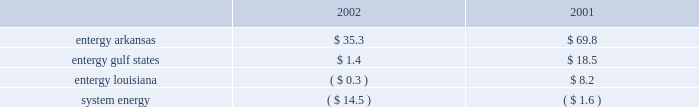Domestic utility companies and system energy notes to respective financial statements derived from another portion of the entity that continues to apply sfas 71 should not be written off ; rather , they should be considered regulatory assets of the segment that will continue to apply sfas 71 .
See note 2 to the domestic utility companies and system energy financial statements for discussion of transition to competition activity in the retail regulatory jurisdictions served by the domestic utility companies .
Only texas currently has an enacted retail open access law , but entergy believes that significant issues remain to be addressed by regulators , and the enacted law does not provide sufficient detail to reasonably determine the impact on entergy gulf states' regulated operations .
Cash and cash equivalents entergy considers all unrestricted highly liquid debt instruments purchased with an original maturity of three months or less to be cash equivalents .
Investments with original maturities of more than three months are classified as other temporary investments on the balance sheet .
Investments entergy applies the provisions of sfas 115 , 201caccounting for investments for certain debt and equity securities , 201d in accounting for investments in decommissioning trust funds .
As a result , entergy records the decommissioning trust funds at their fair value on the balance sheet .
As of december 31 , 2002 and 2001 , the fair value of the securities held in such funds differs from the amounts deposited plus the earnings on the deposits by the following ( in millions ) : .
In accordance with the regulatory treatment for decommissioning trust funds , entergy arkansas , entergy gulf states ( for the regulated portion of river bend ) , and entergy louisiana have recorded an offsetting amount of unrealized gains/ ( losses ) on investment securities in accumulated depreciation .
For the nonregulated portion of river bend , entergy gulf states has recorded an offsetting amount of unrealized gains/ ( losses ) in other deferred credits .
System energy's offsetting amount of unrealized gains/ ( losses ) on investment securities is in other regulatory liabilities .
Derivatives and hedging entergy implemented sfas 133 , 201caccounting for derivative instruments and hedging activities 201d on january 1 , 2001 .
The statement requires that all derivatives be recognized in the balance sheet , either as assets or liabilities , at fair value .
The changes in the fair value of derivatives are recorded each period in current earnings or other comprehensive income , depending on whether a derivative is designated as part of a hedge transaction and , if it is , the type of hedge transaction .
For cash-flow hedge transactions in which entergy is hedging the variability of cash flows related to a variable-rate asset , liability , or forecasted transaction , changes in the fair value of the derivative instrument are reported in other comprehensive income .
The gains and losses on the derivative instrument that are reported in other comprehensive income are reclassified as earnings in the periods in which earnings are impacted by the variability of the cash flows of the hedged item .
The ineffective portions of all hedges are recognized in current- period earnings .
Contracts for commodities that will be delivered in quantities expected to be used or sold in the ordinary course of business , including certain purchases and sales of power and fuel , are not classified as derivatives. .
What is the percent change in the difference in the fair value of the securities held in decommissioning trust funds and the amounts deposited plus the earnings on the deposits from 2001 to 2002 for entergy gulf states? 
Computations: ((18.5 - 1.4) / 1.4)
Answer: 12.21429. Domestic utility companies and system energy notes to respective financial statements derived from another portion of the entity that continues to apply sfas 71 should not be written off ; rather , they should be considered regulatory assets of the segment that will continue to apply sfas 71 .
See note 2 to the domestic utility companies and system energy financial statements for discussion of transition to competition activity in the retail regulatory jurisdictions served by the domestic utility companies .
Only texas currently has an enacted retail open access law , but entergy believes that significant issues remain to be addressed by regulators , and the enacted law does not provide sufficient detail to reasonably determine the impact on entergy gulf states' regulated operations .
Cash and cash equivalents entergy considers all unrestricted highly liquid debt instruments purchased with an original maturity of three months or less to be cash equivalents .
Investments with original maturities of more than three months are classified as other temporary investments on the balance sheet .
Investments entergy applies the provisions of sfas 115 , 201caccounting for investments for certain debt and equity securities , 201d in accounting for investments in decommissioning trust funds .
As a result , entergy records the decommissioning trust funds at their fair value on the balance sheet .
As of december 31 , 2002 and 2001 , the fair value of the securities held in such funds differs from the amounts deposited plus the earnings on the deposits by the following ( in millions ) : .
In accordance with the regulatory treatment for decommissioning trust funds , entergy arkansas , entergy gulf states ( for the regulated portion of river bend ) , and entergy louisiana have recorded an offsetting amount of unrealized gains/ ( losses ) on investment securities in accumulated depreciation .
For the nonregulated portion of river bend , entergy gulf states has recorded an offsetting amount of unrealized gains/ ( losses ) in other deferred credits .
System energy's offsetting amount of unrealized gains/ ( losses ) on investment securities is in other regulatory liabilities .
Derivatives and hedging entergy implemented sfas 133 , 201caccounting for derivative instruments and hedging activities 201d on january 1 , 2001 .
The statement requires that all derivatives be recognized in the balance sheet , either as assets or liabilities , at fair value .
The changes in the fair value of derivatives are recorded each period in current earnings or other comprehensive income , depending on whether a derivative is designated as part of a hedge transaction and , if it is , the type of hedge transaction .
For cash-flow hedge transactions in which entergy is hedging the variability of cash flows related to a variable-rate asset , liability , or forecasted transaction , changes in the fair value of the derivative instrument are reported in other comprehensive income .
The gains and losses on the derivative instrument that are reported in other comprehensive income are reclassified as earnings in the periods in which earnings are impacted by the variability of the cash flows of the hedged item .
The ineffective portions of all hedges are recognized in current- period earnings .
Contracts for commodities that will be delivered in quantities expected to be used or sold in the ordinary course of business , including certain purchases and sales of power and fuel , are not classified as derivatives. .
What is the percent change in the difference in the fair value of the securities held in decommissioning trust funds and the amounts deposited plus the earnings on the deposits from 2001 to 2002 for entergy arkansas? 
Computations: ((69.8 - 35.3) / 35.3)
Answer: 0.97734. 